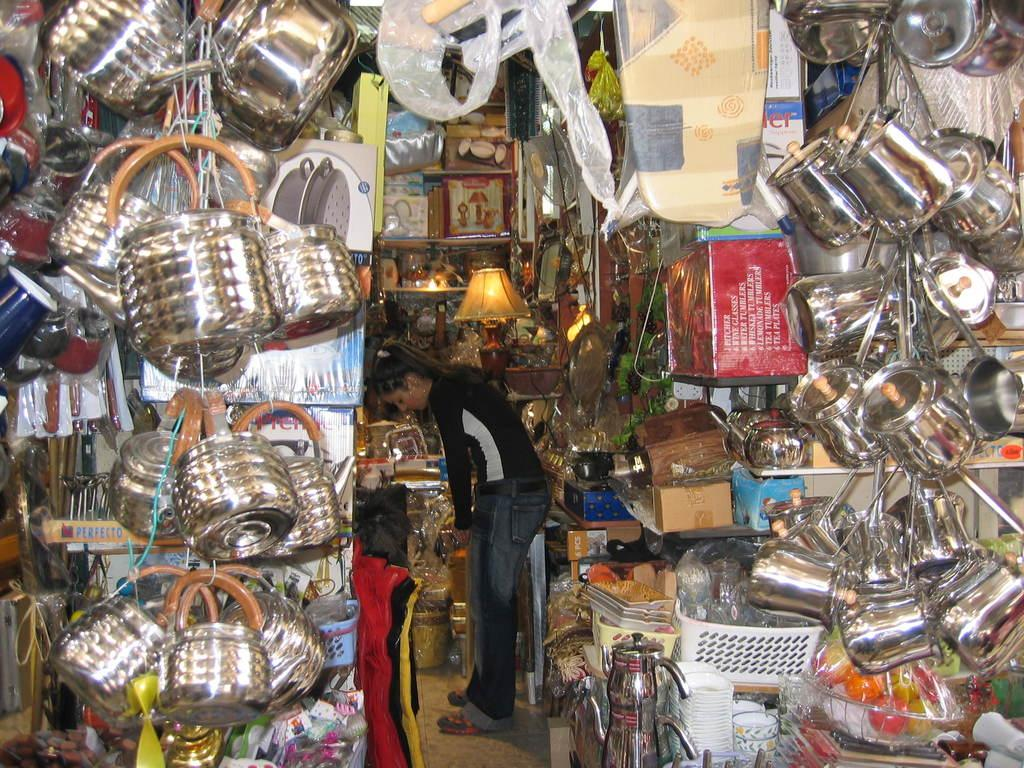What types of containers are visible in the image? There are jars, bowls, kettles, and containers in the image. What other objects can be seen in the image? There is a lamp and buckets in the image. Are there any other objects present in the image? Yes, there are other objects in the image. Can you describe the woman in the image? There is a woman standing on the floor in the image. What is the tendency of the ghost in the image? There is no ghost present in the image, so it is not possible to determine any tendencies. 